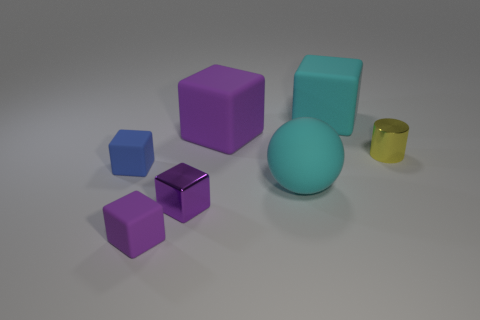What color is the small metallic cylinder?
Offer a very short reply. Yellow. What shape is the large rubber thing that is the same color as the large rubber sphere?
Give a very brief answer. Cube. What color is the metallic cube that is the same size as the yellow cylinder?
Your response must be concise. Purple. What number of rubber things are either purple cubes or tiny cubes?
Your answer should be very brief. 3. What number of small things are both to the right of the blue matte cube and on the left side of the cylinder?
Your answer should be compact. 2. Is there anything else that has the same shape as the tiny yellow shiny thing?
Your answer should be compact. No. How many other things are the same size as the blue thing?
Give a very brief answer. 3. There is a cyan thing that is behind the small yellow metal thing; does it have the same size as the shiny thing in front of the blue object?
Your answer should be compact. No. How many things are either purple metallic cubes or metal things in front of the blue thing?
Offer a very short reply. 1. There is a cube on the left side of the small purple matte thing; how big is it?
Keep it short and to the point. Small. 